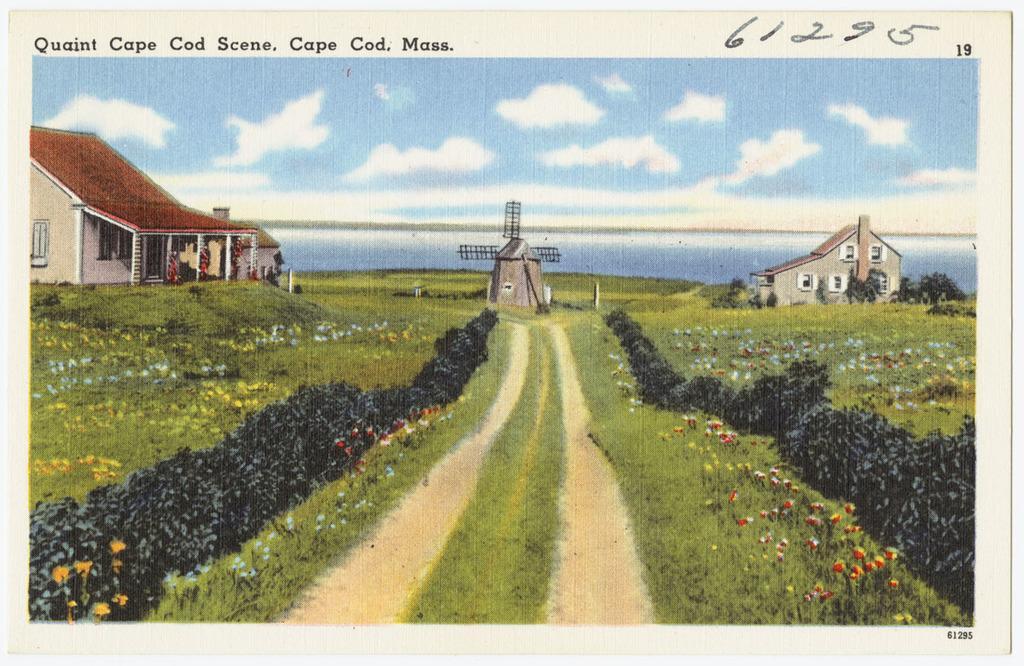How would you summarize this image in a sentence or two? In this image we can see a picture of houses with roof and windows. We can also see some plants, grass, a pathway, a windmill, a large water body, poles and the sky which looks cloudy. On the top of the image we can see some printed text and some written numbers. 